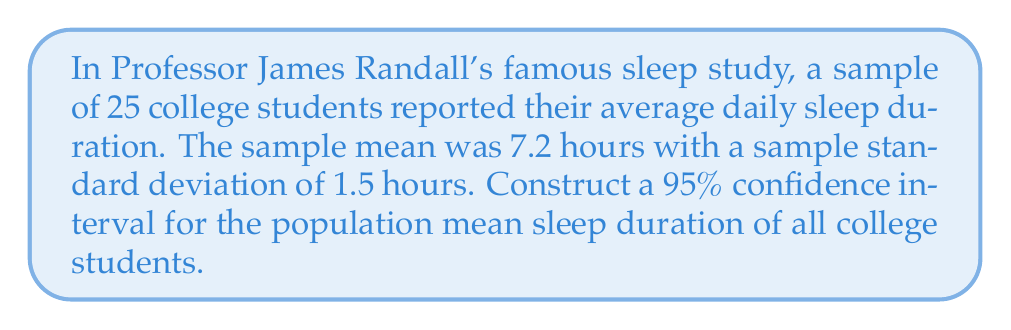What is the answer to this math problem? Let's construct the confidence interval step by step:

1) We're dealing with a small sample size (n < 30) and the population standard deviation is unknown, so we'll use the t-distribution.

2) The formula for the confidence interval is:

   $$\bar{x} \pm t_{\alpha/2, n-1} \cdot \frac{s}{\sqrt{n}}$$

   where $\bar{x}$ is the sample mean, $s$ is the sample standard deviation, $n$ is the sample size, and $t_{\alpha/2, n-1}$ is the t-value for the desired confidence level with $n-1$ degrees of freedom.

3) We have:
   $\bar{x} = 7.2$
   $s = 1.5$
   $n = 25$
   Confidence level = 95%, so $\alpha = 0.05$

4) Degrees of freedom = $n - 1 = 25 - 1 = 24$

5) From the t-table, we find $t_{0.025, 24} = 2.064$

6) Now let's calculate the margin of error:

   $$t_{\alpha/2, n-1} \cdot \frac{s}{\sqrt{n}} = 2.064 \cdot \frac{1.5}{\sqrt{25}} = 2.064 \cdot 0.3 = 0.6192$$

7) The confidence interval is:

   $$7.2 \pm 0.6192$$

8) Therefore, the 95% confidence interval is (7.2 - 0.6192, 7.2 + 0.6192) or (6.5808, 7.8192)
Answer: (6.5808, 7.8192) hours 